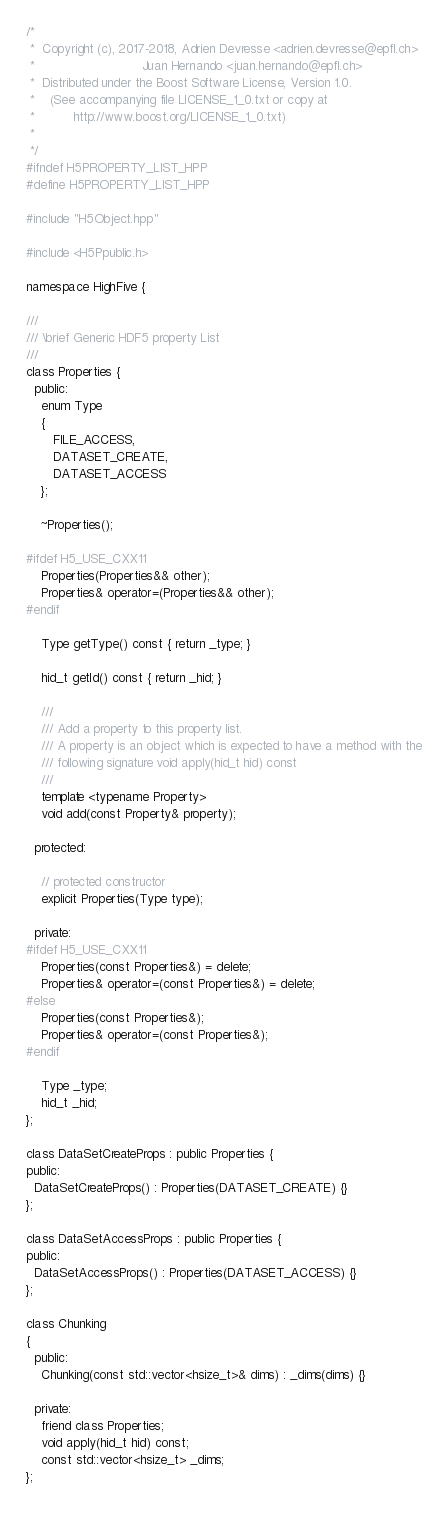Convert code to text. <code><loc_0><loc_0><loc_500><loc_500><_C++_>/*
 *  Copyright (c), 2017-2018, Adrien Devresse <adrien.devresse@epfl.ch>
 *                            Juan Hernando <juan.hernando@epfl.ch>
 *  Distributed under the Boost Software License, Version 1.0.
 *    (See accompanying file LICENSE_1_0.txt or copy at
 *          http://www.boost.org/LICENSE_1_0.txt)
 *
 */
#ifndef H5PROPERTY_LIST_HPP
#define H5PROPERTY_LIST_HPP

#include "H5Object.hpp"

#include <H5Ppublic.h>

namespace HighFive {

///
/// \brief Generic HDF5 property List
///
class Properties {
  public:
    enum Type
    {
       FILE_ACCESS,
       DATASET_CREATE,
       DATASET_ACCESS
    };

    ~Properties();

#ifdef H5_USE_CXX11
    Properties(Properties&& other);
    Properties& operator=(Properties&& other);
#endif

    Type getType() const { return _type; }

    hid_t getId() const { return _hid; }

    ///
    /// Add a property to this property list.
    /// A property is an object which is expected to have a method with the
    /// following signature void apply(hid_t hid) const
    ///
    template <typename Property>
    void add(const Property& property);

  protected:

    // protected constructor
    explicit Properties(Type type);

  private:
#ifdef H5_USE_CXX11
    Properties(const Properties&) = delete;
    Properties& operator=(const Properties&) = delete;
#else
    Properties(const Properties&);
    Properties& operator=(const Properties&);
#endif

    Type _type;
    hid_t _hid;
};

class DataSetCreateProps : public Properties {
public:
  DataSetCreateProps() : Properties(DATASET_CREATE) {}
};

class DataSetAccessProps : public Properties {
public:
  DataSetAccessProps() : Properties(DATASET_ACCESS) {}
};

class Chunking
{
  public:
    Chunking(const std::vector<hsize_t>& dims) : _dims(dims) {}

  private:
    friend class Properties;
    void apply(hid_t hid) const;
    const std::vector<hsize_t> _dims;
};
</code> 